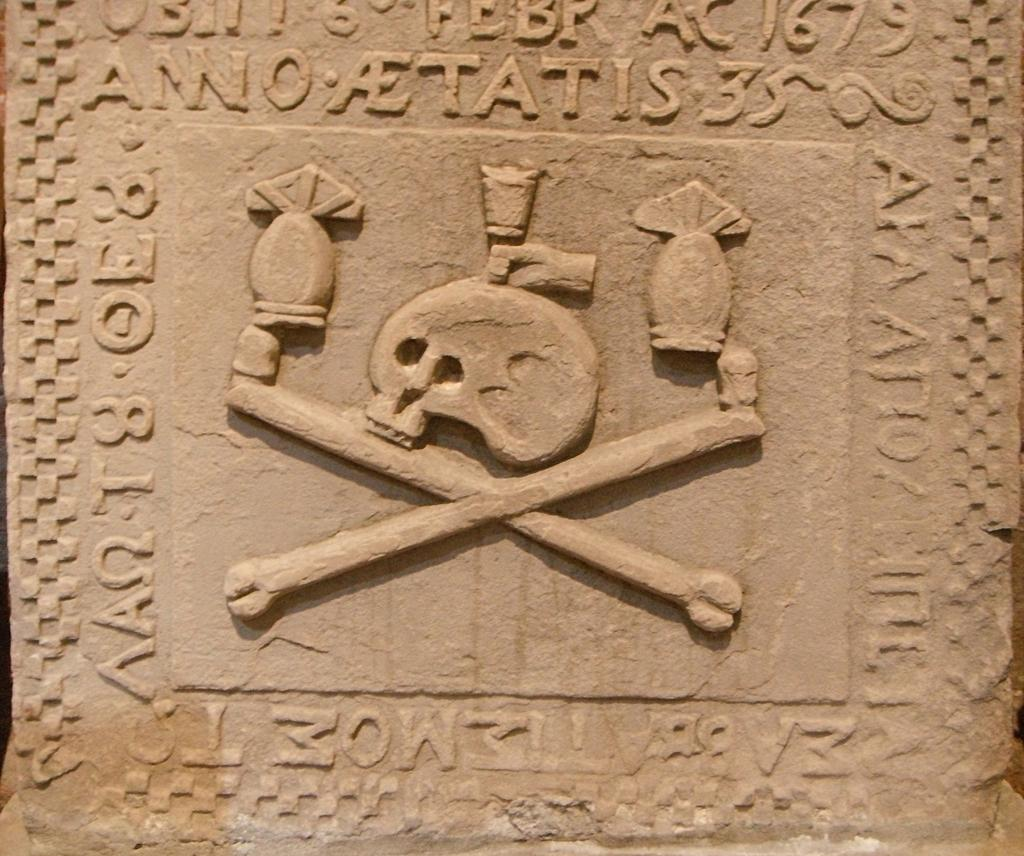What is the main feature of the image? There is a wall in the image. What type of pie is being served by your aunt in the image? There is no aunt or pie present in the image; it only features a wall. 